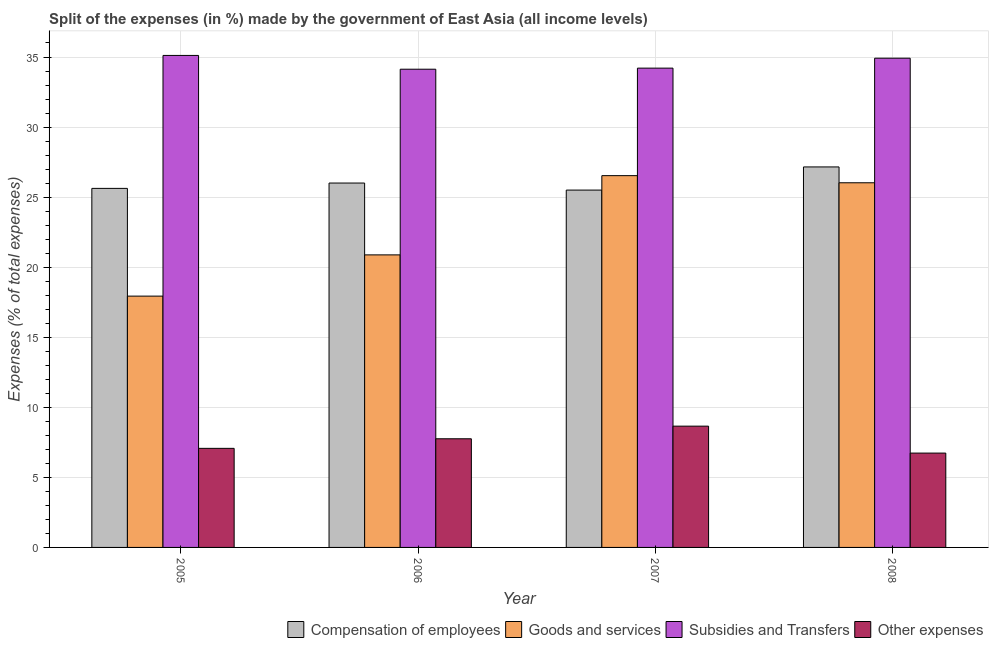How many different coloured bars are there?
Your answer should be very brief. 4. How many groups of bars are there?
Keep it short and to the point. 4. Are the number of bars per tick equal to the number of legend labels?
Offer a terse response. Yes. Are the number of bars on each tick of the X-axis equal?
Provide a succinct answer. Yes. How many bars are there on the 2nd tick from the left?
Provide a short and direct response. 4. How many bars are there on the 4th tick from the right?
Your answer should be compact. 4. What is the percentage of amount spent on compensation of employees in 2008?
Your answer should be very brief. 27.15. Across all years, what is the maximum percentage of amount spent on compensation of employees?
Keep it short and to the point. 27.15. Across all years, what is the minimum percentage of amount spent on other expenses?
Give a very brief answer. 6.73. In which year was the percentage of amount spent on subsidies maximum?
Make the answer very short. 2005. In which year was the percentage of amount spent on subsidies minimum?
Make the answer very short. 2006. What is the total percentage of amount spent on other expenses in the graph?
Give a very brief answer. 30.21. What is the difference between the percentage of amount spent on compensation of employees in 2005 and that in 2007?
Provide a short and direct response. 0.12. What is the difference between the percentage of amount spent on goods and services in 2008 and the percentage of amount spent on subsidies in 2007?
Offer a terse response. -0.51. What is the average percentage of amount spent on compensation of employees per year?
Keep it short and to the point. 26.07. In the year 2005, what is the difference between the percentage of amount spent on compensation of employees and percentage of amount spent on other expenses?
Provide a short and direct response. 0. What is the ratio of the percentage of amount spent on compensation of employees in 2005 to that in 2006?
Give a very brief answer. 0.99. What is the difference between the highest and the second highest percentage of amount spent on subsidies?
Ensure brevity in your answer.  0.2. What is the difference between the highest and the lowest percentage of amount spent on other expenses?
Make the answer very short. 1.92. In how many years, is the percentage of amount spent on subsidies greater than the average percentage of amount spent on subsidies taken over all years?
Ensure brevity in your answer.  2. Is the sum of the percentage of amount spent on other expenses in 2005 and 2006 greater than the maximum percentage of amount spent on compensation of employees across all years?
Make the answer very short. Yes. Is it the case that in every year, the sum of the percentage of amount spent on compensation of employees and percentage of amount spent on subsidies is greater than the sum of percentage of amount spent on other expenses and percentage of amount spent on goods and services?
Offer a very short reply. No. What does the 2nd bar from the left in 2008 represents?
Offer a terse response. Goods and services. What does the 3rd bar from the right in 2008 represents?
Provide a short and direct response. Goods and services. Is it the case that in every year, the sum of the percentage of amount spent on compensation of employees and percentage of amount spent on goods and services is greater than the percentage of amount spent on subsidies?
Provide a short and direct response. Yes. How many bars are there?
Give a very brief answer. 16. Are all the bars in the graph horizontal?
Make the answer very short. No. How many years are there in the graph?
Provide a short and direct response. 4. What is the difference between two consecutive major ticks on the Y-axis?
Your response must be concise. 5. Are the values on the major ticks of Y-axis written in scientific E-notation?
Offer a terse response. No. Does the graph contain any zero values?
Offer a very short reply. No. Does the graph contain grids?
Your response must be concise. Yes. Where does the legend appear in the graph?
Your response must be concise. Bottom right. How many legend labels are there?
Make the answer very short. 4. What is the title of the graph?
Your answer should be compact. Split of the expenses (in %) made by the government of East Asia (all income levels). What is the label or title of the X-axis?
Keep it short and to the point. Year. What is the label or title of the Y-axis?
Make the answer very short. Expenses (% of total expenses). What is the Expenses (% of total expenses) of Compensation of employees in 2005?
Give a very brief answer. 25.62. What is the Expenses (% of total expenses) in Goods and services in 2005?
Your answer should be very brief. 17.94. What is the Expenses (% of total expenses) of Subsidies and Transfers in 2005?
Offer a terse response. 35.11. What is the Expenses (% of total expenses) in Other expenses in 2005?
Your answer should be very brief. 7.07. What is the Expenses (% of total expenses) of Compensation of employees in 2006?
Provide a short and direct response. 26.01. What is the Expenses (% of total expenses) of Goods and services in 2006?
Make the answer very short. 20.88. What is the Expenses (% of total expenses) of Subsidies and Transfers in 2006?
Offer a very short reply. 34.13. What is the Expenses (% of total expenses) in Other expenses in 2006?
Keep it short and to the point. 7.75. What is the Expenses (% of total expenses) of Compensation of employees in 2007?
Provide a succinct answer. 25.5. What is the Expenses (% of total expenses) of Goods and services in 2007?
Make the answer very short. 26.53. What is the Expenses (% of total expenses) in Subsidies and Transfers in 2007?
Offer a terse response. 34.21. What is the Expenses (% of total expenses) in Other expenses in 2007?
Offer a very short reply. 8.65. What is the Expenses (% of total expenses) of Compensation of employees in 2008?
Ensure brevity in your answer.  27.15. What is the Expenses (% of total expenses) in Goods and services in 2008?
Your response must be concise. 26.02. What is the Expenses (% of total expenses) in Subsidies and Transfers in 2008?
Keep it short and to the point. 34.91. What is the Expenses (% of total expenses) of Other expenses in 2008?
Your answer should be compact. 6.73. Across all years, what is the maximum Expenses (% of total expenses) in Compensation of employees?
Your answer should be very brief. 27.15. Across all years, what is the maximum Expenses (% of total expenses) of Goods and services?
Give a very brief answer. 26.53. Across all years, what is the maximum Expenses (% of total expenses) of Subsidies and Transfers?
Your answer should be very brief. 35.11. Across all years, what is the maximum Expenses (% of total expenses) in Other expenses?
Ensure brevity in your answer.  8.65. Across all years, what is the minimum Expenses (% of total expenses) of Compensation of employees?
Your answer should be very brief. 25.5. Across all years, what is the minimum Expenses (% of total expenses) in Goods and services?
Keep it short and to the point. 17.94. Across all years, what is the minimum Expenses (% of total expenses) of Subsidies and Transfers?
Offer a very short reply. 34.13. Across all years, what is the minimum Expenses (% of total expenses) of Other expenses?
Offer a terse response. 6.73. What is the total Expenses (% of total expenses) in Compensation of employees in the graph?
Provide a succinct answer. 104.29. What is the total Expenses (% of total expenses) of Goods and services in the graph?
Ensure brevity in your answer.  91.37. What is the total Expenses (% of total expenses) of Subsidies and Transfers in the graph?
Keep it short and to the point. 138.36. What is the total Expenses (% of total expenses) of Other expenses in the graph?
Your answer should be very brief. 30.21. What is the difference between the Expenses (% of total expenses) of Compensation of employees in 2005 and that in 2006?
Give a very brief answer. -0.38. What is the difference between the Expenses (% of total expenses) of Goods and services in 2005 and that in 2006?
Offer a very short reply. -2.94. What is the difference between the Expenses (% of total expenses) of Subsidies and Transfers in 2005 and that in 2006?
Ensure brevity in your answer.  0.98. What is the difference between the Expenses (% of total expenses) in Other expenses in 2005 and that in 2006?
Provide a short and direct response. -0.68. What is the difference between the Expenses (% of total expenses) of Compensation of employees in 2005 and that in 2007?
Ensure brevity in your answer.  0.12. What is the difference between the Expenses (% of total expenses) of Goods and services in 2005 and that in 2007?
Provide a succinct answer. -8.6. What is the difference between the Expenses (% of total expenses) of Subsidies and Transfers in 2005 and that in 2007?
Offer a terse response. 0.91. What is the difference between the Expenses (% of total expenses) of Other expenses in 2005 and that in 2007?
Offer a terse response. -1.58. What is the difference between the Expenses (% of total expenses) in Compensation of employees in 2005 and that in 2008?
Your response must be concise. -1.53. What is the difference between the Expenses (% of total expenses) of Goods and services in 2005 and that in 2008?
Your answer should be very brief. -8.09. What is the difference between the Expenses (% of total expenses) in Subsidies and Transfers in 2005 and that in 2008?
Offer a terse response. 0.2. What is the difference between the Expenses (% of total expenses) in Other expenses in 2005 and that in 2008?
Give a very brief answer. 0.34. What is the difference between the Expenses (% of total expenses) of Compensation of employees in 2006 and that in 2007?
Ensure brevity in your answer.  0.5. What is the difference between the Expenses (% of total expenses) in Goods and services in 2006 and that in 2007?
Keep it short and to the point. -5.65. What is the difference between the Expenses (% of total expenses) in Subsidies and Transfers in 2006 and that in 2007?
Make the answer very short. -0.08. What is the difference between the Expenses (% of total expenses) in Other expenses in 2006 and that in 2007?
Make the answer very short. -0.9. What is the difference between the Expenses (% of total expenses) of Compensation of employees in 2006 and that in 2008?
Provide a succinct answer. -1.15. What is the difference between the Expenses (% of total expenses) in Goods and services in 2006 and that in 2008?
Provide a short and direct response. -5.15. What is the difference between the Expenses (% of total expenses) in Subsidies and Transfers in 2006 and that in 2008?
Offer a very short reply. -0.79. What is the difference between the Expenses (% of total expenses) of Other expenses in 2006 and that in 2008?
Keep it short and to the point. 1.02. What is the difference between the Expenses (% of total expenses) of Compensation of employees in 2007 and that in 2008?
Your answer should be compact. -1.65. What is the difference between the Expenses (% of total expenses) of Goods and services in 2007 and that in 2008?
Your answer should be compact. 0.51. What is the difference between the Expenses (% of total expenses) in Subsidies and Transfers in 2007 and that in 2008?
Your answer should be very brief. -0.71. What is the difference between the Expenses (% of total expenses) in Other expenses in 2007 and that in 2008?
Ensure brevity in your answer.  1.92. What is the difference between the Expenses (% of total expenses) of Compensation of employees in 2005 and the Expenses (% of total expenses) of Goods and services in 2006?
Offer a terse response. 4.75. What is the difference between the Expenses (% of total expenses) of Compensation of employees in 2005 and the Expenses (% of total expenses) of Subsidies and Transfers in 2006?
Provide a succinct answer. -8.51. What is the difference between the Expenses (% of total expenses) of Compensation of employees in 2005 and the Expenses (% of total expenses) of Other expenses in 2006?
Provide a short and direct response. 17.87. What is the difference between the Expenses (% of total expenses) in Goods and services in 2005 and the Expenses (% of total expenses) in Subsidies and Transfers in 2006?
Give a very brief answer. -16.19. What is the difference between the Expenses (% of total expenses) in Goods and services in 2005 and the Expenses (% of total expenses) in Other expenses in 2006?
Your response must be concise. 10.18. What is the difference between the Expenses (% of total expenses) of Subsidies and Transfers in 2005 and the Expenses (% of total expenses) of Other expenses in 2006?
Your response must be concise. 27.36. What is the difference between the Expenses (% of total expenses) of Compensation of employees in 2005 and the Expenses (% of total expenses) of Goods and services in 2007?
Your response must be concise. -0.91. What is the difference between the Expenses (% of total expenses) of Compensation of employees in 2005 and the Expenses (% of total expenses) of Subsidies and Transfers in 2007?
Offer a terse response. -8.58. What is the difference between the Expenses (% of total expenses) of Compensation of employees in 2005 and the Expenses (% of total expenses) of Other expenses in 2007?
Provide a short and direct response. 16.97. What is the difference between the Expenses (% of total expenses) in Goods and services in 2005 and the Expenses (% of total expenses) in Subsidies and Transfers in 2007?
Provide a succinct answer. -16.27. What is the difference between the Expenses (% of total expenses) in Goods and services in 2005 and the Expenses (% of total expenses) in Other expenses in 2007?
Offer a terse response. 9.28. What is the difference between the Expenses (% of total expenses) in Subsidies and Transfers in 2005 and the Expenses (% of total expenses) in Other expenses in 2007?
Keep it short and to the point. 26.46. What is the difference between the Expenses (% of total expenses) in Compensation of employees in 2005 and the Expenses (% of total expenses) in Goods and services in 2008?
Provide a succinct answer. -0.4. What is the difference between the Expenses (% of total expenses) of Compensation of employees in 2005 and the Expenses (% of total expenses) of Subsidies and Transfers in 2008?
Provide a succinct answer. -9.29. What is the difference between the Expenses (% of total expenses) in Compensation of employees in 2005 and the Expenses (% of total expenses) in Other expenses in 2008?
Offer a terse response. 18.89. What is the difference between the Expenses (% of total expenses) of Goods and services in 2005 and the Expenses (% of total expenses) of Subsidies and Transfers in 2008?
Ensure brevity in your answer.  -16.98. What is the difference between the Expenses (% of total expenses) in Goods and services in 2005 and the Expenses (% of total expenses) in Other expenses in 2008?
Make the answer very short. 11.2. What is the difference between the Expenses (% of total expenses) in Subsidies and Transfers in 2005 and the Expenses (% of total expenses) in Other expenses in 2008?
Provide a succinct answer. 28.38. What is the difference between the Expenses (% of total expenses) of Compensation of employees in 2006 and the Expenses (% of total expenses) of Goods and services in 2007?
Your answer should be compact. -0.53. What is the difference between the Expenses (% of total expenses) in Compensation of employees in 2006 and the Expenses (% of total expenses) in Subsidies and Transfers in 2007?
Keep it short and to the point. -8.2. What is the difference between the Expenses (% of total expenses) in Compensation of employees in 2006 and the Expenses (% of total expenses) in Other expenses in 2007?
Give a very brief answer. 17.35. What is the difference between the Expenses (% of total expenses) of Goods and services in 2006 and the Expenses (% of total expenses) of Subsidies and Transfers in 2007?
Your answer should be compact. -13.33. What is the difference between the Expenses (% of total expenses) in Goods and services in 2006 and the Expenses (% of total expenses) in Other expenses in 2007?
Ensure brevity in your answer.  12.22. What is the difference between the Expenses (% of total expenses) of Subsidies and Transfers in 2006 and the Expenses (% of total expenses) of Other expenses in 2007?
Your answer should be very brief. 25.47. What is the difference between the Expenses (% of total expenses) of Compensation of employees in 2006 and the Expenses (% of total expenses) of Goods and services in 2008?
Provide a succinct answer. -0.02. What is the difference between the Expenses (% of total expenses) in Compensation of employees in 2006 and the Expenses (% of total expenses) in Subsidies and Transfers in 2008?
Your response must be concise. -8.91. What is the difference between the Expenses (% of total expenses) of Compensation of employees in 2006 and the Expenses (% of total expenses) of Other expenses in 2008?
Make the answer very short. 19.27. What is the difference between the Expenses (% of total expenses) of Goods and services in 2006 and the Expenses (% of total expenses) of Subsidies and Transfers in 2008?
Ensure brevity in your answer.  -14.04. What is the difference between the Expenses (% of total expenses) of Goods and services in 2006 and the Expenses (% of total expenses) of Other expenses in 2008?
Make the answer very short. 14.15. What is the difference between the Expenses (% of total expenses) in Subsidies and Transfers in 2006 and the Expenses (% of total expenses) in Other expenses in 2008?
Ensure brevity in your answer.  27.4. What is the difference between the Expenses (% of total expenses) of Compensation of employees in 2007 and the Expenses (% of total expenses) of Goods and services in 2008?
Offer a terse response. -0.52. What is the difference between the Expenses (% of total expenses) in Compensation of employees in 2007 and the Expenses (% of total expenses) in Subsidies and Transfers in 2008?
Keep it short and to the point. -9.41. What is the difference between the Expenses (% of total expenses) in Compensation of employees in 2007 and the Expenses (% of total expenses) in Other expenses in 2008?
Provide a short and direct response. 18.77. What is the difference between the Expenses (% of total expenses) of Goods and services in 2007 and the Expenses (% of total expenses) of Subsidies and Transfers in 2008?
Ensure brevity in your answer.  -8.38. What is the difference between the Expenses (% of total expenses) of Goods and services in 2007 and the Expenses (% of total expenses) of Other expenses in 2008?
Give a very brief answer. 19.8. What is the difference between the Expenses (% of total expenses) of Subsidies and Transfers in 2007 and the Expenses (% of total expenses) of Other expenses in 2008?
Make the answer very short. 27.47. What is the average Expenses (% of total expenses) in Compensation of employees per year?
Provide a short and direct response. 26.07. What is the average Expenses (% of total expenses) of Goods and services per year?
Give a very brief answer. 22.84. What is the average Expenses (% of total expenses) of Subsidies and Transfers per year?
Your answer should be compact. 34.59. What is the average Expenses (% of total expenses) in Other expenses per year?
Offer a terse response. 7.55. In the year 2005, what is the difference between the Expenses (% of total expenses) in Compensation of employees and Expenses (% of total expenses) in Goods and services?
Your response must be concise. 7.69. In the year 2005, what is the difference between the Expenses (% of total expenses) of Compensation of employees and Expenses (% of total expenses) of Subsidies and Transfers?
Your answer should be compact. -9.49. In the year 2005, what is the difference between the Expenses (% of total expenses) in Compensation of employees and Expenses (% of total expenses) in Other expenses?
Offer a terse response. 18.55. In the year 2005, what is the difference between the Expenses (% of total expenses) of Goods and services and Expenses (% of total expenses) of Subsidies and Transfers?
Make the answer very short. -17.18. In the year 2005, what is the difference between the Expenses (% of total expenses) of Goods and services and Expenses (% of total expenses) of Other expenses?
Your response must be concise. 10.86. In the year 2005, what is the difference between the Expenses (% of total expenses) of Subsidies and Transfers and Expenses (% of total expenses) of Other expenses?
Your answer should be very brief. 28.04. In the year 2006, what is the difference between the Expenses (% of total expenses) of Compensation of employees and Expenses (% of total expenses) of Goods and services?
Your answer should be compact. 5.13. In the year 2006, what is the difference between the Expenses (% of total expenses) of Compensation of employees and Expenses (% of total expenses) of Subsidies and Transfers?
Provide a short and direct response. -8.12. In the year 2006, what is the difference between the Expenses (% of total expenses) in Compensation of employees and Expenses (% of total expenses) in Other expenses?
Offer a terse response. 18.25. In the year 2006, what is the difference between the Expenses (% of total expenses) in Goods and services and Expenses (% of total expenses) in Subsidies and Transfers?
Your answer should be compact. -13.25. In the year 2006, what is the difference between the Expenses (% of total expenses) in Goods and services and Expenses (% of total expenses) in Other expenses?
Offer a terse response. 13.12. In the year 2006, what is the difference between the Expenses (% of total expenses) in Subsidies and Transfers and Expenses (% of total expenses) in Other expenses?
Ensure brevity in your answer.  26.37. In the year 2007, what is the difference between the Expenses (% of total expenses) in Compensation of employees and Expenses (% of total expenses) in Goods and services?
Keep it short and to the point. -1.03. In the year 2007, what is the difference between the Expenses (% of total expenses) of Compensation of employees and Expenses (% of total expenses) of Subsidies and Transfers?
Make the answer very short. -8.7. In the year 2007, what is the difference between the Expenses (% of total expenses) of Compensation of employees and Expenses (% of total expenses) of Other expenses?
Make the answer very short. 16.85. In the year 2007, what is the difference between the Expenses (% of total expenses) of Goods and services and Expenses (% of total expenses) of Subsidies and Transfers?
Keep it short and to the point. -7.67. In the year 2007, what is the difference between the Expenses (% of total expenses) in Goods and services and Expenses (% of total expenses) in Other expenses?
Ensure brevity in your answer.  17.88. In the year 2007, what is the difference between the Expenses (% of total expenses) of Subsidies and Transfers and Expenses (% of total expenses) of Other expenses?
Ensure brevity in your answer.  25.55. In the year 2008, what is the difference between the Expenses (% of total expenses) of Compensation of employees and Expenses (% of total expenses) of Goods and services?
Offer a very short reply. 1.13. In the year 2008, what is the difference between the Expenses (% of total expenses) of Compensation of employees and Expenses (% of total expenses) of Subsidies and Transfers?
Ensure brevity in your answer.  -7.76. In the year 2008, what is the difference between the Expenses (% of total expenses) in Compensation of employees and Expenses (% of total expenses) in Other expenses?
Make the answer very short. 20.42. In the year 2008, what is the difference between the Expenses (% of total expenses) of Goods and services and Expenses (% of total expenses) of Subsidies and Transfers?
Your response must be concise. -8.89. In the year 2008, what is the difference between the Expenses (% of total expenses) in Goods and services and Expenses (% of total expenses) in Other expenses?
Ensure brevity in your answer.  19.29. In the year 2008, what is the difference between the Expenses (% of total expenses) in Subsidies and Transfers and Expenses (% of total expenses) in Other expenses?
Offer a very short reply. 28.18. What is the ratio of the Expenses (% of total expenses) of Goods and services in 2005 to that in 2006?
Offer a terse response. 0.86. What is the ratio of the Expenses (% of total expenses) of Subsidies and Transfers in 2005 to that in 2006?
Provide a succinct answer. 1.03. What is the ratio of the Expenses (% of total expenses) of Other expenses in 2005 to that in 2006?
Provide a short and direct response. 0.91. What is the ratio of the Expenses (% of total expenses) of Compensation of employees in 2005 to that in 2007?
Keep it short and to the point. 1. What is the ratio of the Expenses (% of total expenses) of Goods and services in 2005 to that in 2007?
Your answer should be very brief. 0.68. What is the ratio of the Expenses (% of total expenses) in Subsidies and Transfers in 2005 to that in 2007?
Your answer should be very brief. 1.03. What is the ratio of the Expenses (% of total expenses) in Other expenses in 2005 to that in 2007?
Provide a succinct answer. 0.82. What is the ratio of the Expenses (% of total expenses) of Compensation of employees in 2005 to that in 2008?
Your response must be concise. 0.94. What is the ratio of the Expenses (% of total expenses) in Goods and services in 2005 to that in 2008?
Your response must be concise. 0.69. What is the ratio of the Expenses (% of total expenses) in Subsidies and Transfers in 2005 to that in 2008?
Your answer should be very brief. 1.01. What is the ratio of the Expenses (% of total expenses) in Other expenses in 2005 to that in 2008?
Your answer should be compact. 1.05. What is the ratio of the Expenses (% of total expenses) in Compensation of employees in 2006 to that in 2007?
Keep it short and to the point. 1.02. What is the ratio of the Expenses (% of total expenses) in Goods and services in 2006 to that in 2007?
Your answer should be compact. 0.79. What is the ratio of the Expenses (% of total expenses) of Other expenses in 2006 to that in 2007?
Offer a very short reply. 0.9. What is the ratio of the Expenses (% of total expenses) of Compensation of employees in 2006 to that in 2008?
Provide a succinct answer. 0.96. What is the ratio of the Expenses (% of total expenses) of Goods and services in 2006 to that in 2008?
Your answer should be very brief. 0.8. What is the ratio of the Expenses (% of total expenses) of Subsidies and Transfers in 2006 to that in 2008?
Keep it short and to the point. 0.98. What is the ratio of the Expenses (% of total expenses) of Other expenses in 2006 to that in 2008?
Provide a succinct answer. 1.15. What is the ratio of the Expenses (% of total expenses) in Compensation of employees in 2007 to that in 2008?
Offer a terse response. 0.94. What is the ratio of the Expenses (% of total expenses) of Goods and services in 2007 to that in 2008?
Give a very brief answer. 1.02. What is the ratio of the Expenses (% of total expenses) of Subsidies and Transfers in 2007 to that in 2008?
Make the answer very short. 0.98. What is the ratio of the Expenses (% of total expenses) of Other expenses in 2007 to that in 2008?
Provide a succinct answer. 1.29. What is the difference between the highest and the second highest Expenses (% of total expenses) of Compensation of employees?
Make the answer very short. 1.15. What is the difference between the highest and the second highest Expenses (% of total expenses) of Goods and services?
Ensure brevity in your answer.  0.51. What is the difference between the highest and the second highest Expenses (% of total expenses) of Subsidies and Transfers?
Give a very brief answer. 0.2. What is the difference between the highest and the second highest Expenses (% of total expenses) in Other expenses?
Give a very brief answer. 0.9. What is the difference between the highest and the lowest Expenses (% of total expenses) of Compensation of employees?
Offer a terse response. 1.65. What is the difference between the highest and the lowest Expenses (% of total expenses) of Goods and services?
Offer a very short reply. 8.6. What is the difference between the highest and the lowest Expenses (% of total expenses) in Subsidies and Transfers?
Keep it short and to the point. 0.98. What is the difference between the highest and the lowest Expenses (% of total expenses) of Other expenses?
Offer a very short reply. 1.92. 